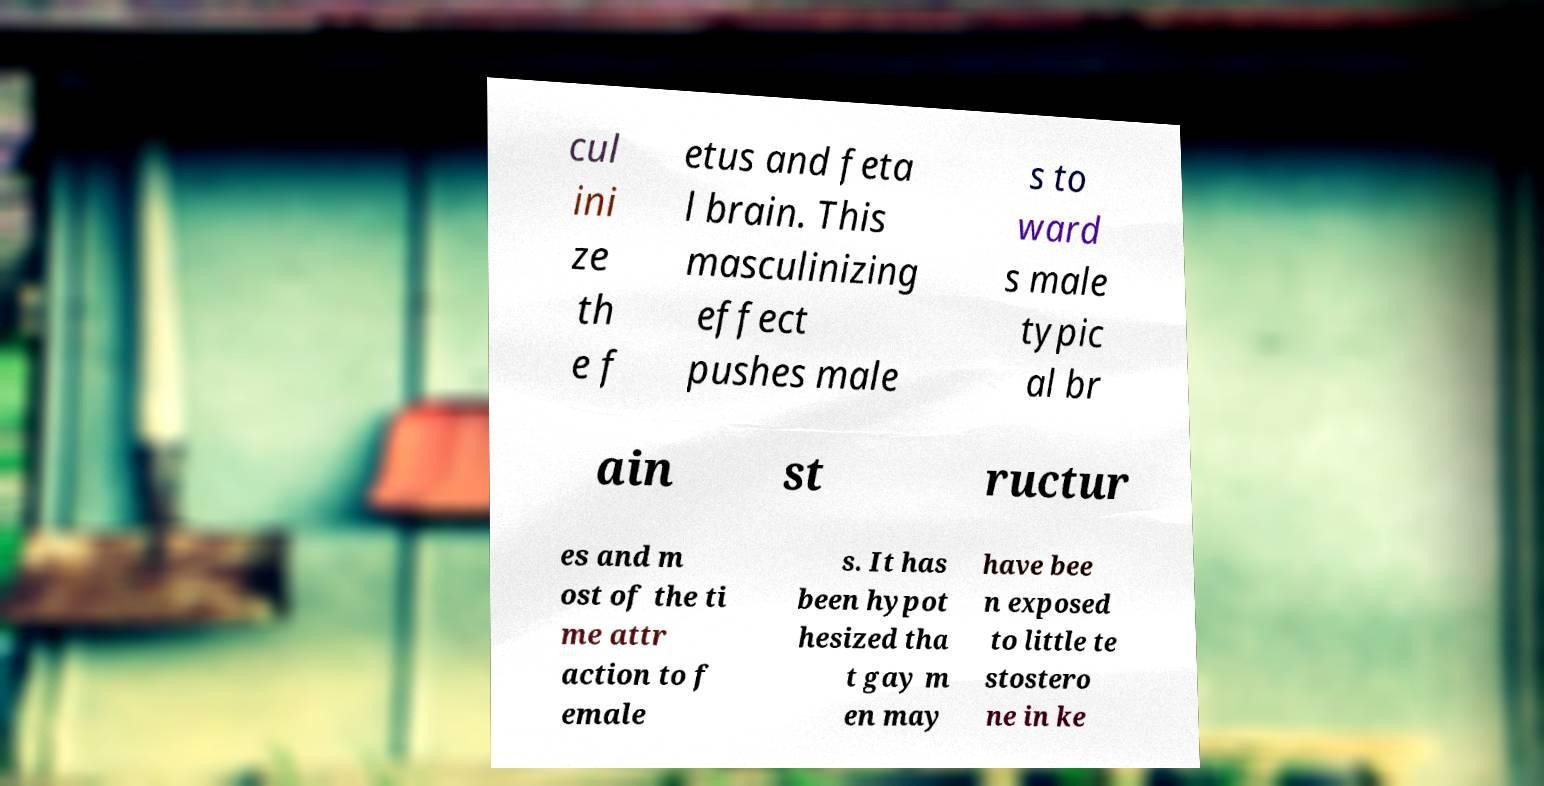For documentation purposes, I need the text within this image transcribed. Could you provide that? cul ini ze th e f etus and feta l brain. This masculinizing effect pushes male s to ward s male typic al br ain st ructur es and m ost of the ti me attr action to f emale s. It has been hypot hesized tha t gay m en may have bee n exposed to little te stostero ne in ke 